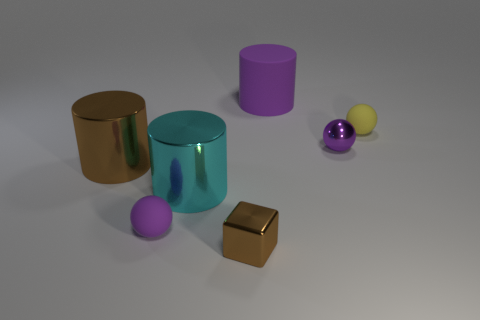Add 3 big purple cylinders. How many objects exist? 10 Subtract all spheres. How many objects are left? 4 Add 6 large purple things. How many large purple things are left? 7 Add 7 small purple objects. How many small purple objects exist? 9 Subtract 0 blue spheres. How many objects are left? 7 Subtract all tiny red matte cylinders. Subtract all yellow balls. How many objects are left? 6 